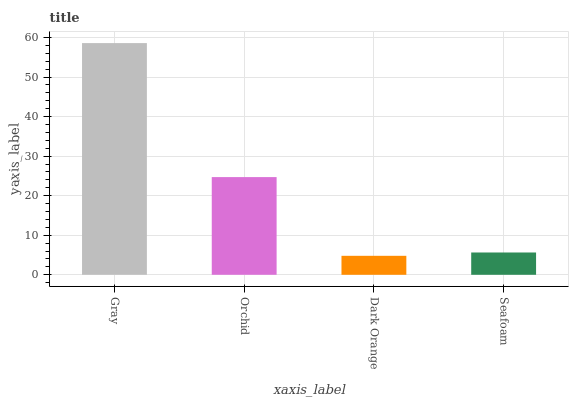Is Dark Orange the minimum?
Answer yes or no. Yes. Is Gray the maximum?
Answer yes or no. Yes. Is Orchid the minimum?
Answer yes or no. No. Is Orchid the maximum?
Answer yes or no. No. Is Gray greater than Orchid?
Answer yes or no. Yes. Is Orchid less than Gray?
Answer yes or no. Yes. Is Orchid greater than Gray?
Answer yes or no. No. Is Gray less than Orchid?
Answer yes or no. No. Is Orchid the high median?
Answer yes or no. Yes. Is Seafoam the low median?
Answer yes or no. Yes. Is Seafoam the high median?
Answer yes or no. No. Is Dark Orange the low median?
Answer yes or no. No. 